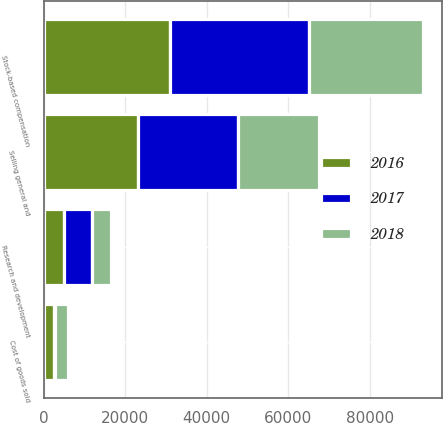Convert chart to OTSL. <chart><loc_0><loc_0><loc_500><loc_500><stacked_bar_chart><ecel><fcel>Cost of goods sold<fcel>Research and development<fcel>Selling general and<fcel>Stock-based compensation<nl><fcel>2017<fcel>157<fcel>6697<fcel>24316<fcel>34170<nl><fcel>2016<fcel>2665<fcel>5068<fcel>23285<fcel>31018<nl><fcel>2018<fcel>3103<fcel>4815<fcel>19879<fcel>27797<nl></chart> 